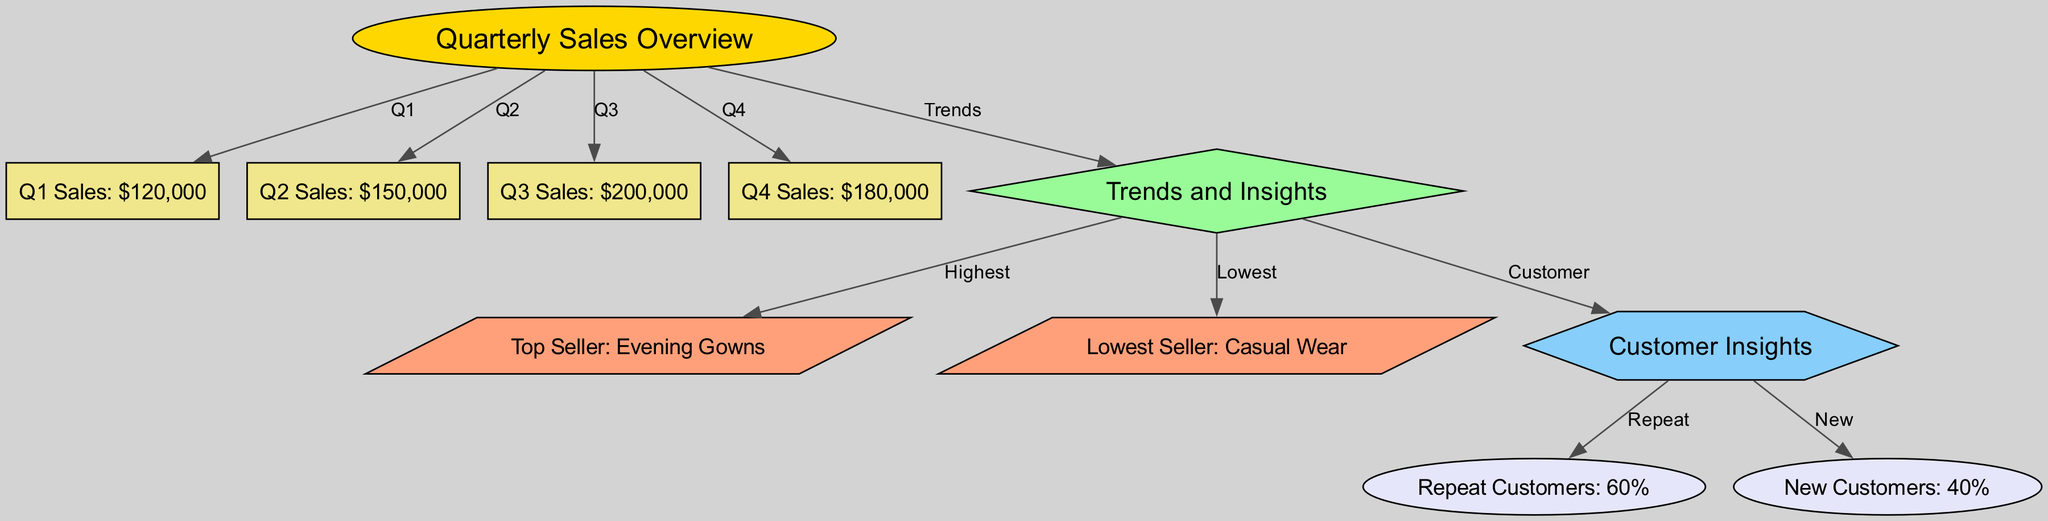What are the total sales for Q3? Looking at the node labeled "Q3 Sales," it indicates that the total sales for Q3 amount to $200,000.
Answer: $200,000 Which quarter had the lowest sales? By comparing the sales values from the nodes for each quarter, the "Q1 Sales" shows the lowest amount at $120,000.
Answer: Q1 What percentage of customers are repeat customers? The node labeled "Repeat Customers" states that 60% of the customers are repeat customers.
Answer: 60% Which type of clothing is the top-selling? In the "Trends and Insights" section, the node labeled "Top Seller" identifies "Evening Gowns" as the best-selling category.
Answer: Evening Gowns What is the total sales amount for the fourth quarter? The "Q4 Sales" node indicates that sales for Q4 are recorded as $180,000.
Answer: $180,000 How many nodes represent sales data in the diagram? By counting the nodes related to sales (Q1, Q2, Q3, Q4), we find there are four nodes specifically for sales data.
Answer: 4 Which quarter demonstrates the highest sales performance? Comparing the sales figures across all quarters in the nodes, "Q3 Sales" is noted for having the highest sales performance at $200,000.
Answer: Q3 What is the percentage of new customers? The node labeled "New Customers" specifies that 40% of the customers are classified as new.
Answer: 40% What is the relationship between trends analysis and customer insights? The diagram shows a direct connection (edge) from the "Trends and Insights" node to the "Customer Insights" node, indicating that trends are examined in the context of customer behavior.
Answer: Direct connection 